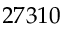Convert formula to latex. <formula><loc_0><loc_0><loc_500><loc_500>2 7 3 1 0</formula> 